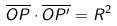<formula> <loc_0><loc_0><loc_500><loc_500>\overline { O P } \cdot \overline { O P ^ { \prime } } = R ^ { 2 }</formula> 